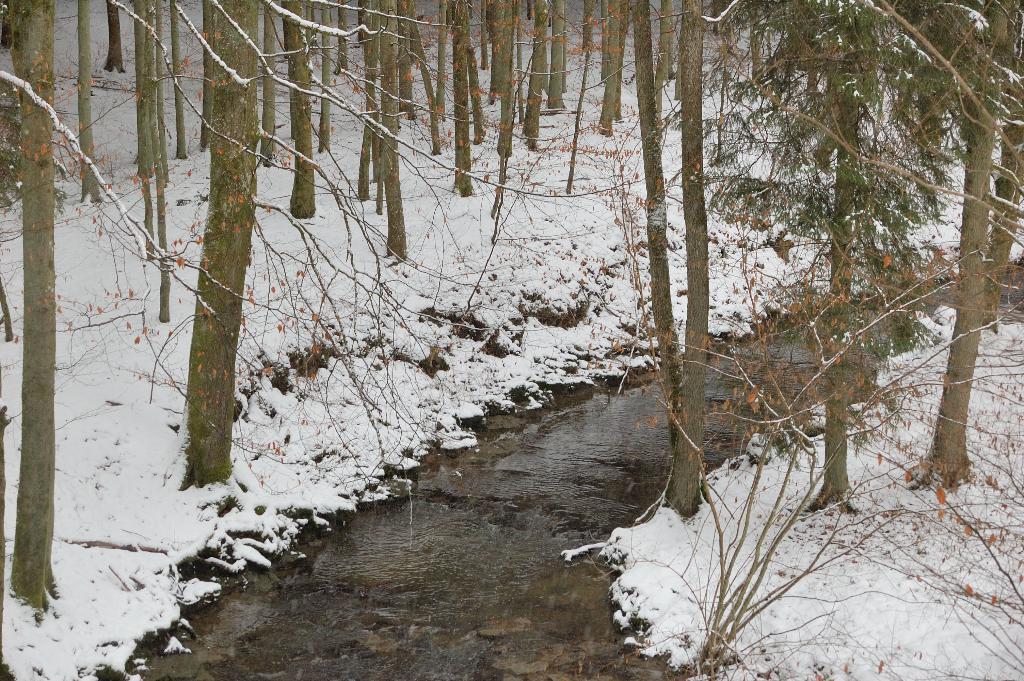Can you describe this image briefly? In this picture we can see water, snow and trees. 